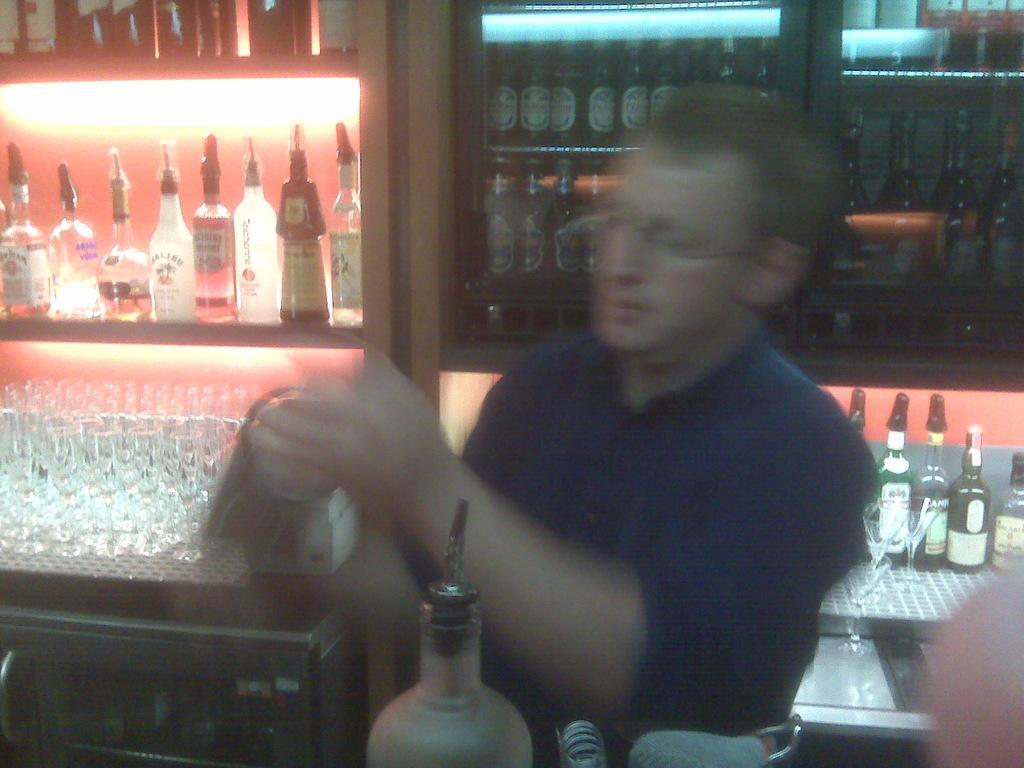Can you describe this image briefly? In this picture there is a man standing. There are few glasses. There are few bottles in the shelf. There are many bottles in the cupboard. 